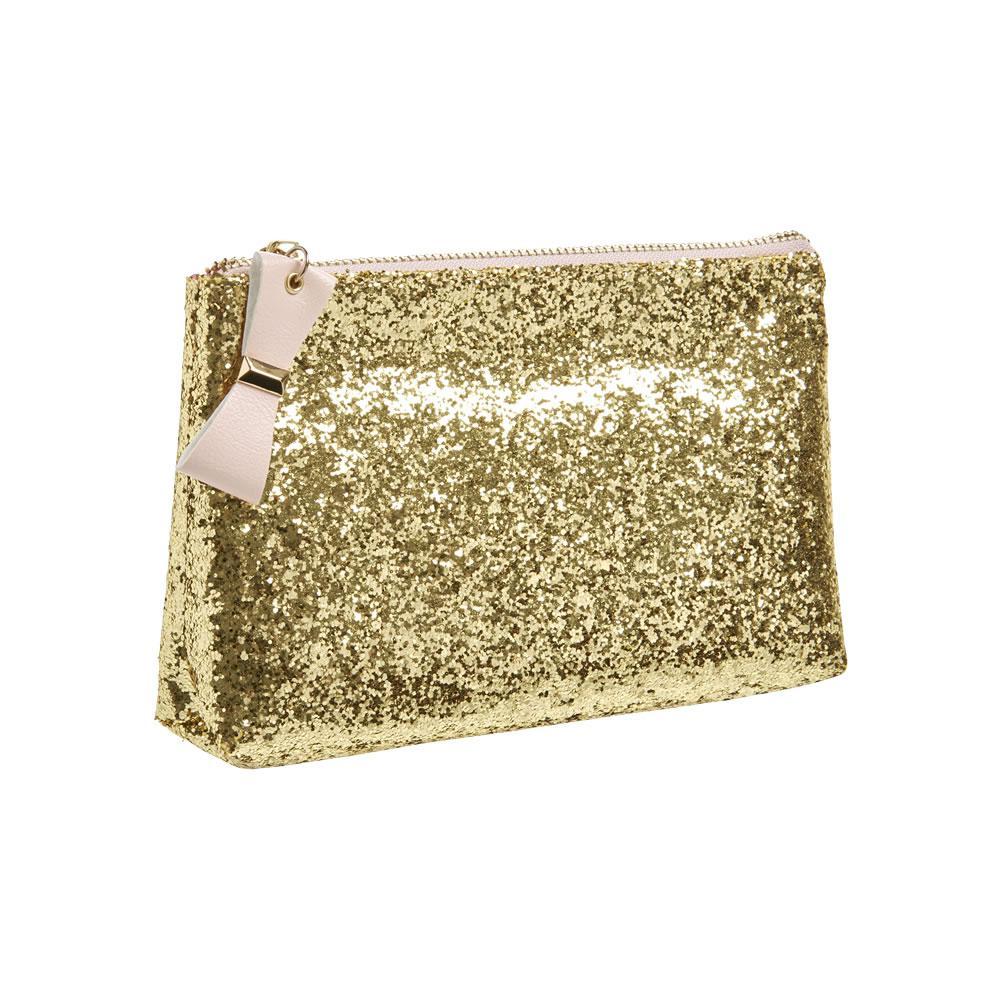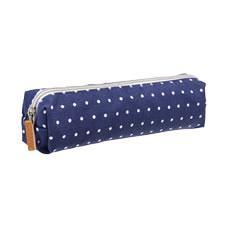The first image is the image on the left, the second image is the image on the right. For the images displayed, is the sentence "There are two pencil cases and they both have a similar long shape." factually correct? Answer yes or no. No. 